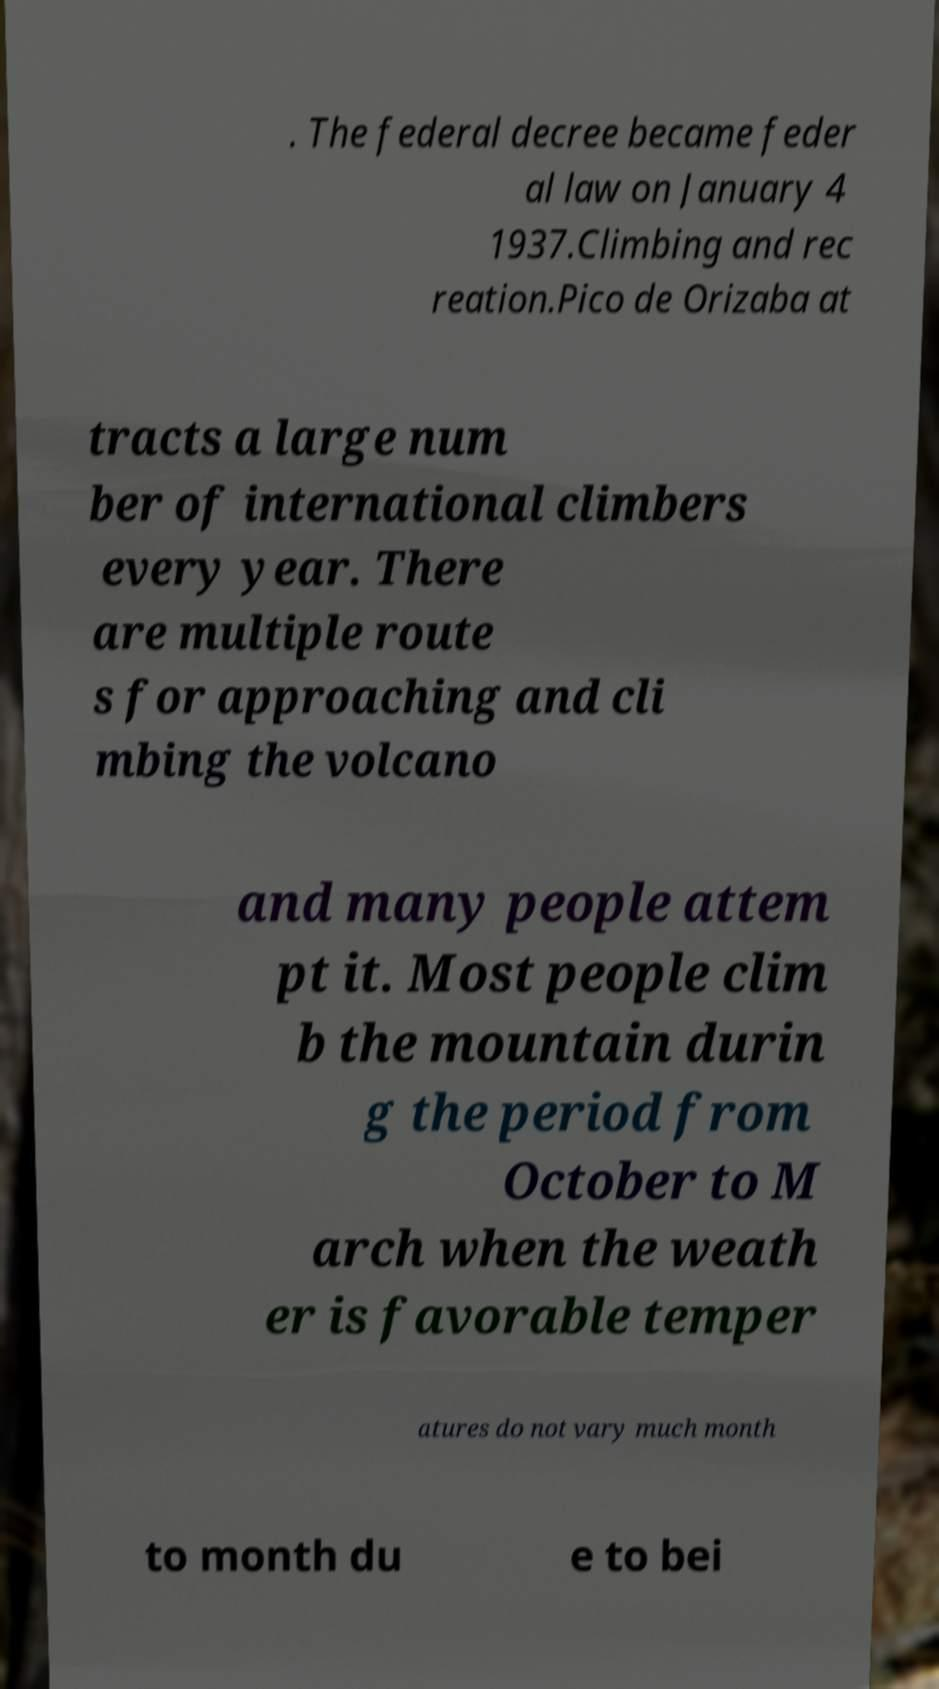Can you accurately transcribe the text from the provided image for me? . The federal decree became feder al law on January 4 1937.Climbing and rec reation.Pico de Orizaba at tracts a large num ber of international climbers every year. There are multiple route s for approaching and cli mbing the volcano and many people attem pt it. Most people clim b the mountain durin g the period from October to M arch when the weath er is favorable temper atures do not vary much month to month du e to bei 